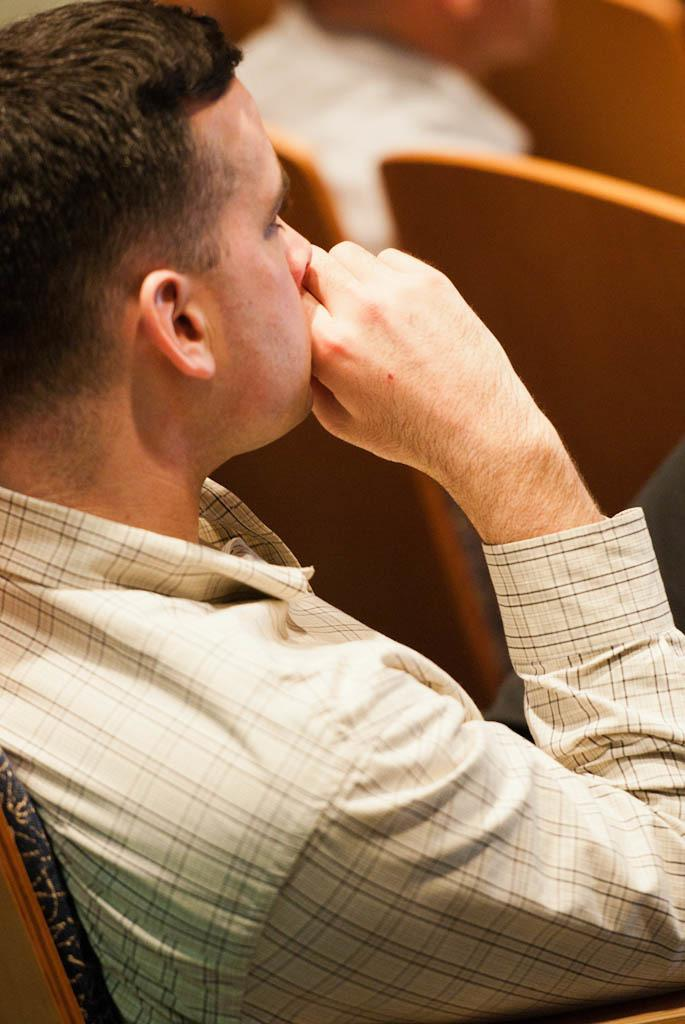What is the person in the image doing? The person is sitting in the image. What is the person wearing? The person is wearing a cream-colored shirt. What can be seen in the background of the image? There are chairs in the background of the image. What color are the chairs? The chairs are brown in color. What time does the clock in the image show? There is no clock present in the image. What type of blade is being used by the person in the image? There is no blade visible in the image; the person is simply sitting. 